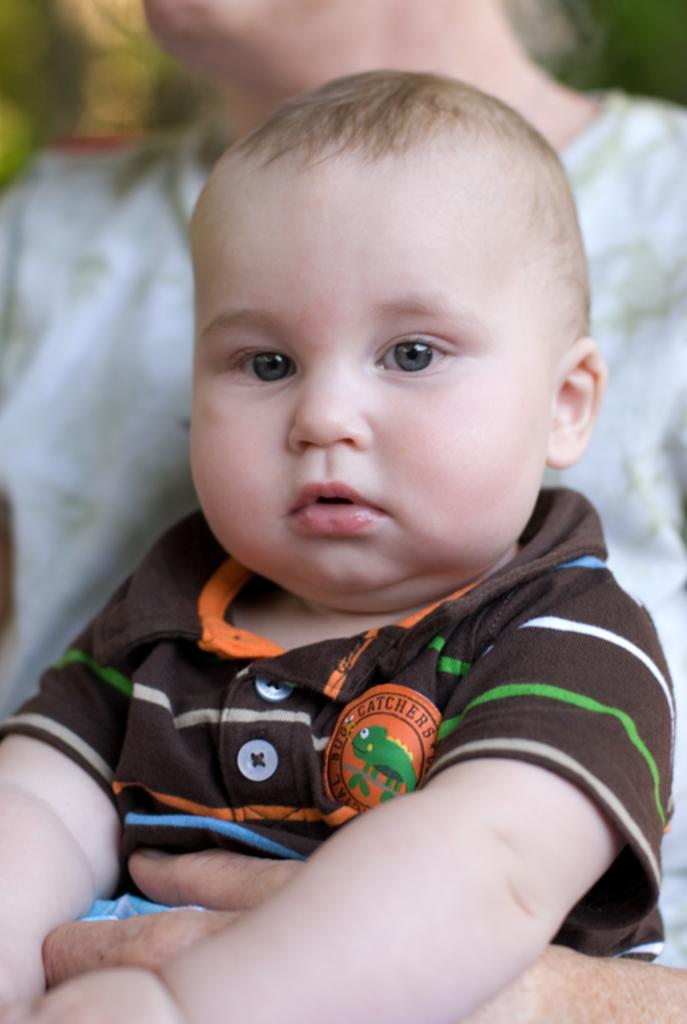What is the main subject of the image? The main subject of the image is a baby. What is the baby wearing in the image? The baby is wearing a brown color T-shirt. Who is present with the baby in the image? There is a woman in the image. What is the woman doing with the baby? The woman is holding the baby. What is the woman wearing in the image? The woman is wearing a white color dress. How many gloves can be seen in the image? There are no gloves present in the image. What type of star can be seen in the image? There is no star present in the image. 